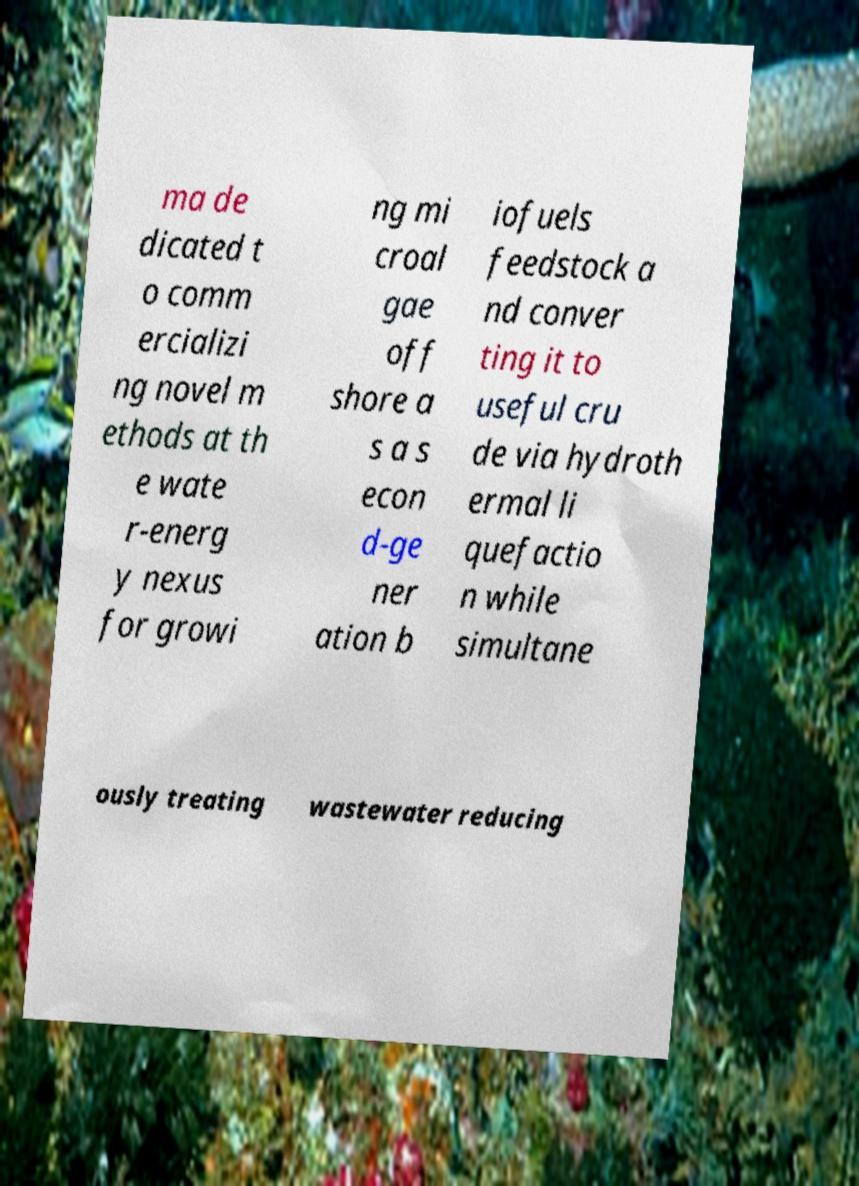For documentation purposes, I need the text within this image transcribed. Could you provide that? ma de dicated t o comm ercializi ng novel m ethods at th e wate r-energ y nexus for growi ng mi croal gae off shore a s a s econ d-ge ner ation b iofuels feedstock a nd conver ting it to useful cru de via hydroth ermal li quefactio n while simultane ously treating wastewater reducing 